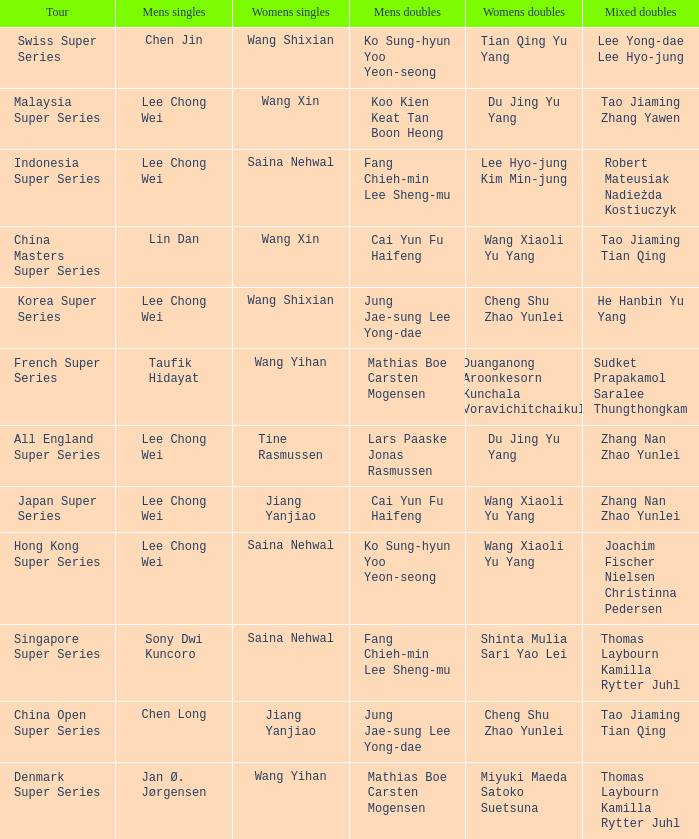Who were the womens doubles when the mixed doubles were zhang nan zhao yunlei on the tour all england super series? Du Jing Yu Yang. 